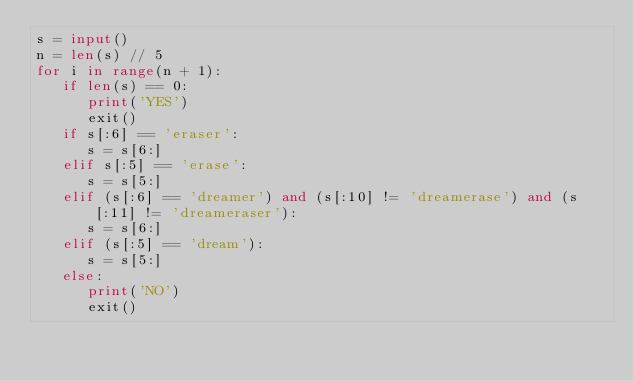<code> <loc_0><loc_0><loc_500><loc_500><_Python_>s = input()
n = len(s) // 5
for i in range(n + 1):
   if len(s) == 0:
      print('YES')
      exit()
   if s[:6] == 'eraser':
      s = s[6:]
   elif s[:5] == 'erase':
      s = s[5:]
   elif (s[:6] == 'dreamer') and (s[:10] != 'dreamerase') and (s[:11] != 'dreameraser'):
      s = s[6:]
   elif (s[:5] == 'dream'):
      s = s[5:]
   else:
      print('NO')
      exit()</code> 